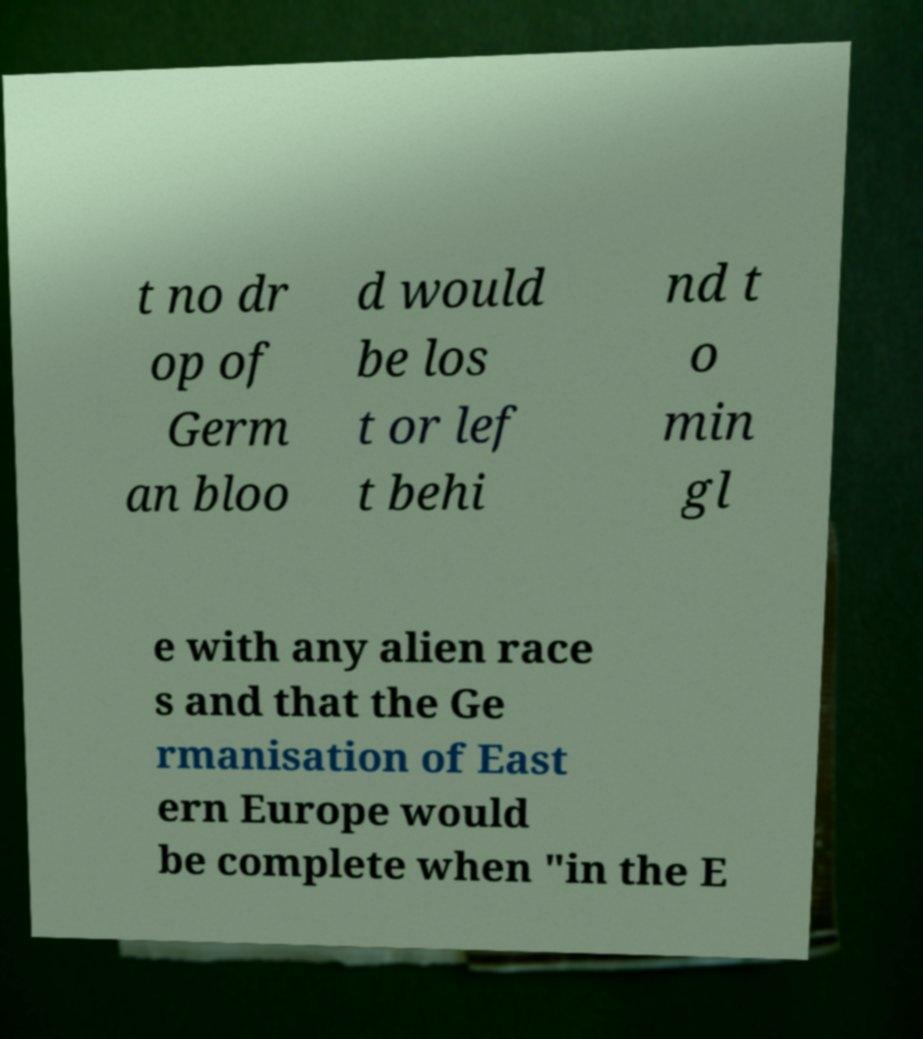Could you assist in decoding the text presented in this image and type it out clearly? t no dr op of Germ an bloo d would be los t or lef t behi nd t o min gl e with any alien race s and that the Ge rmanisation of East ern Europe would be complete when "in the E 